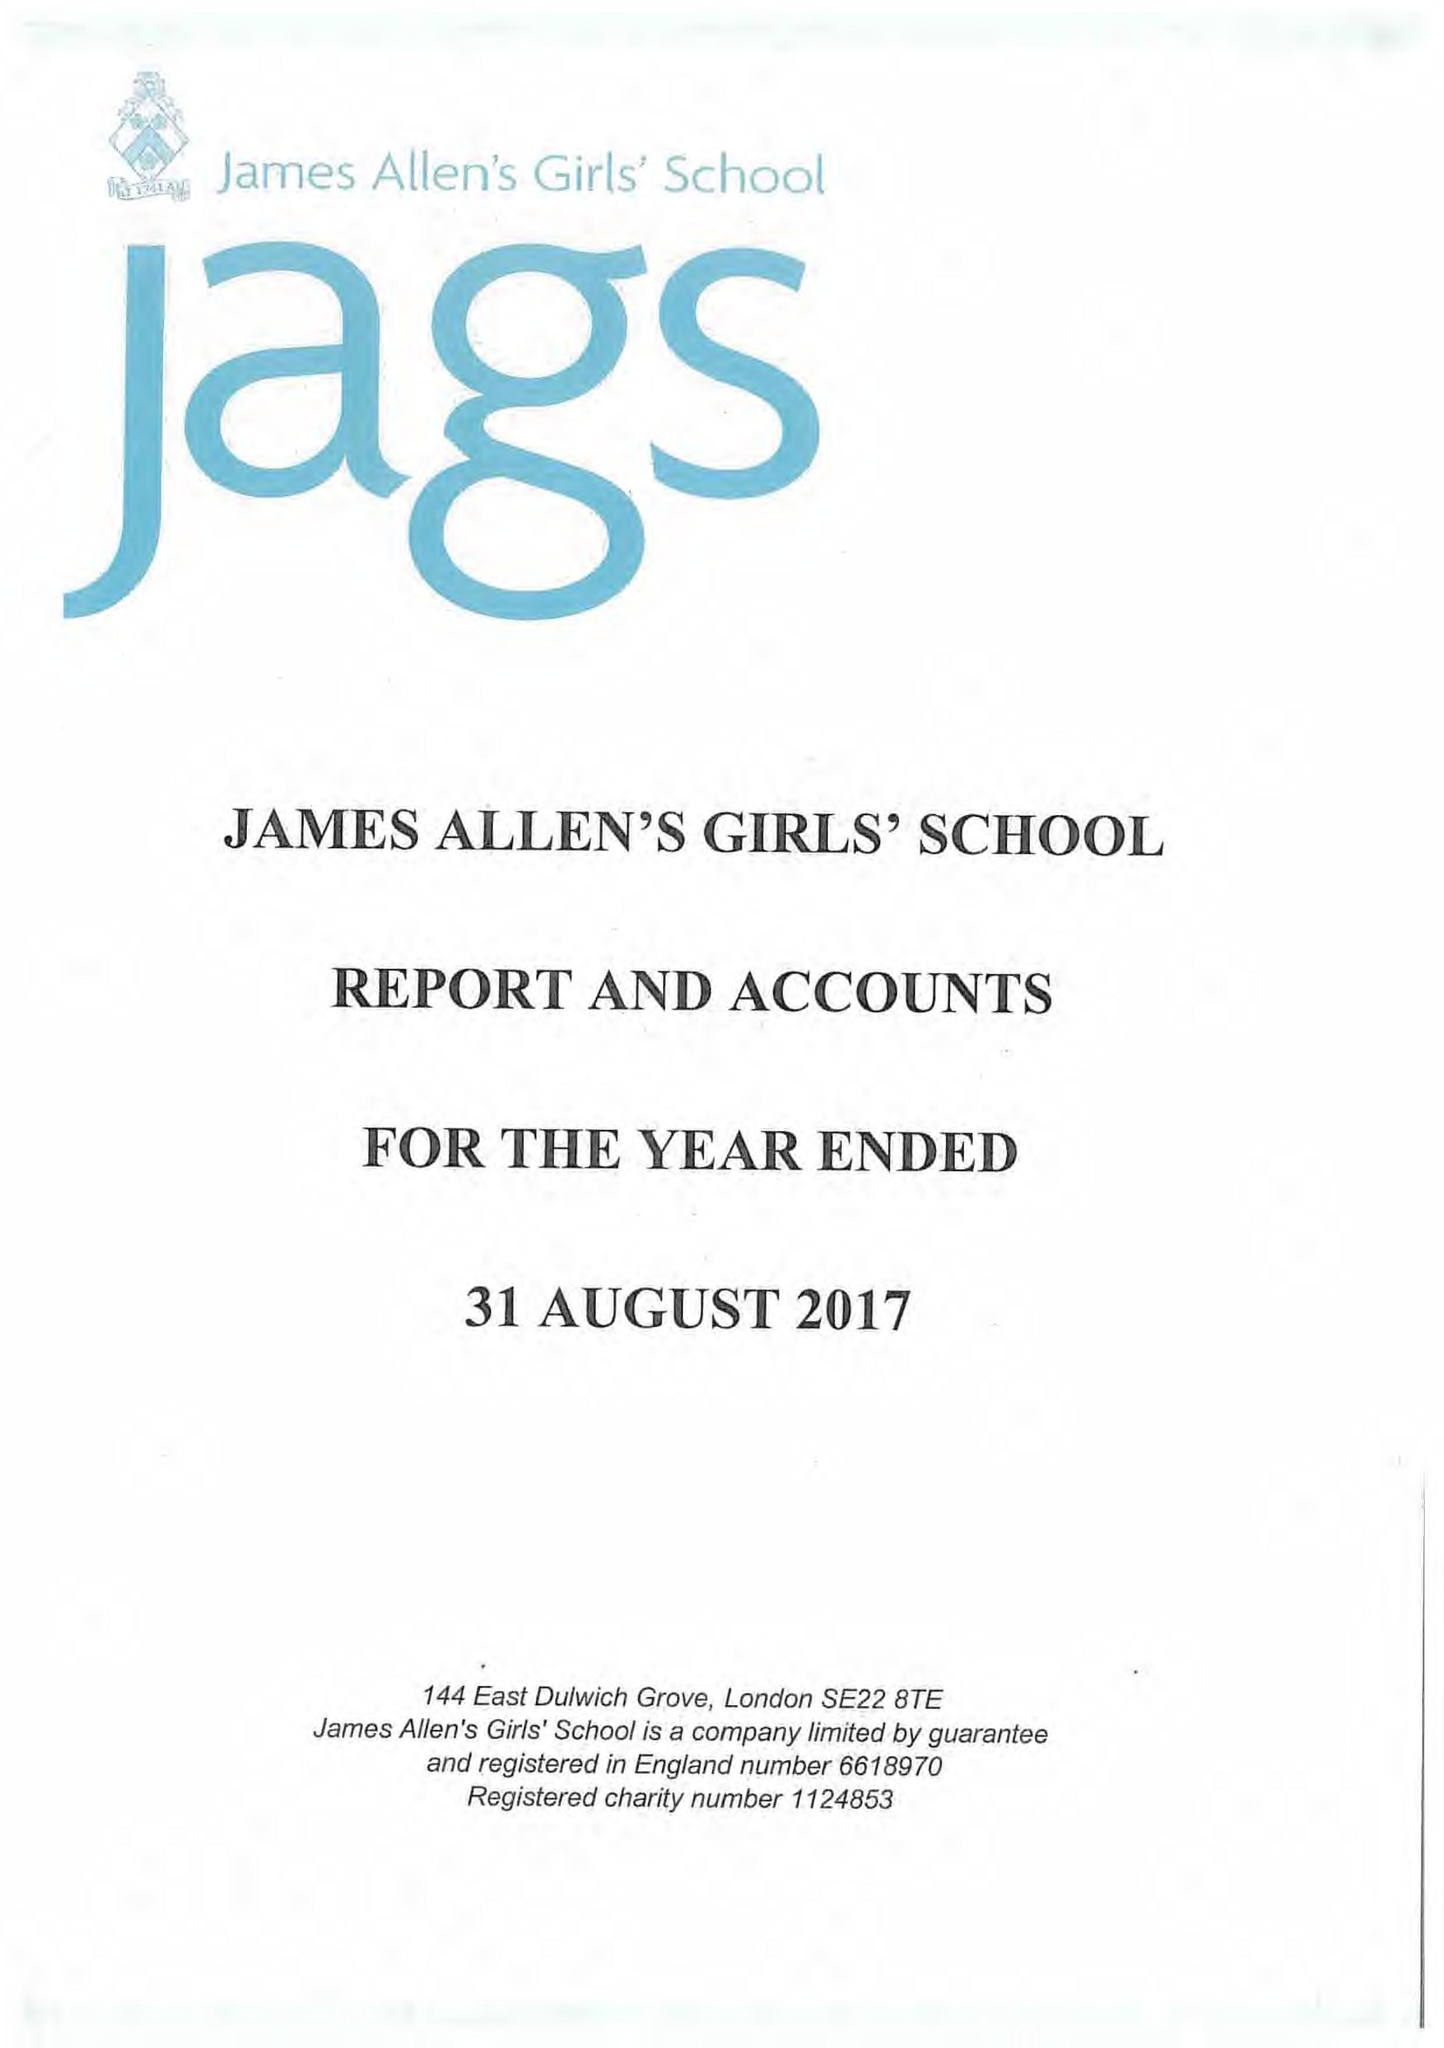What is the value for the address__street_line?
Answer the question using a single word or phrase. 144 EAST DULWICH GROVE 